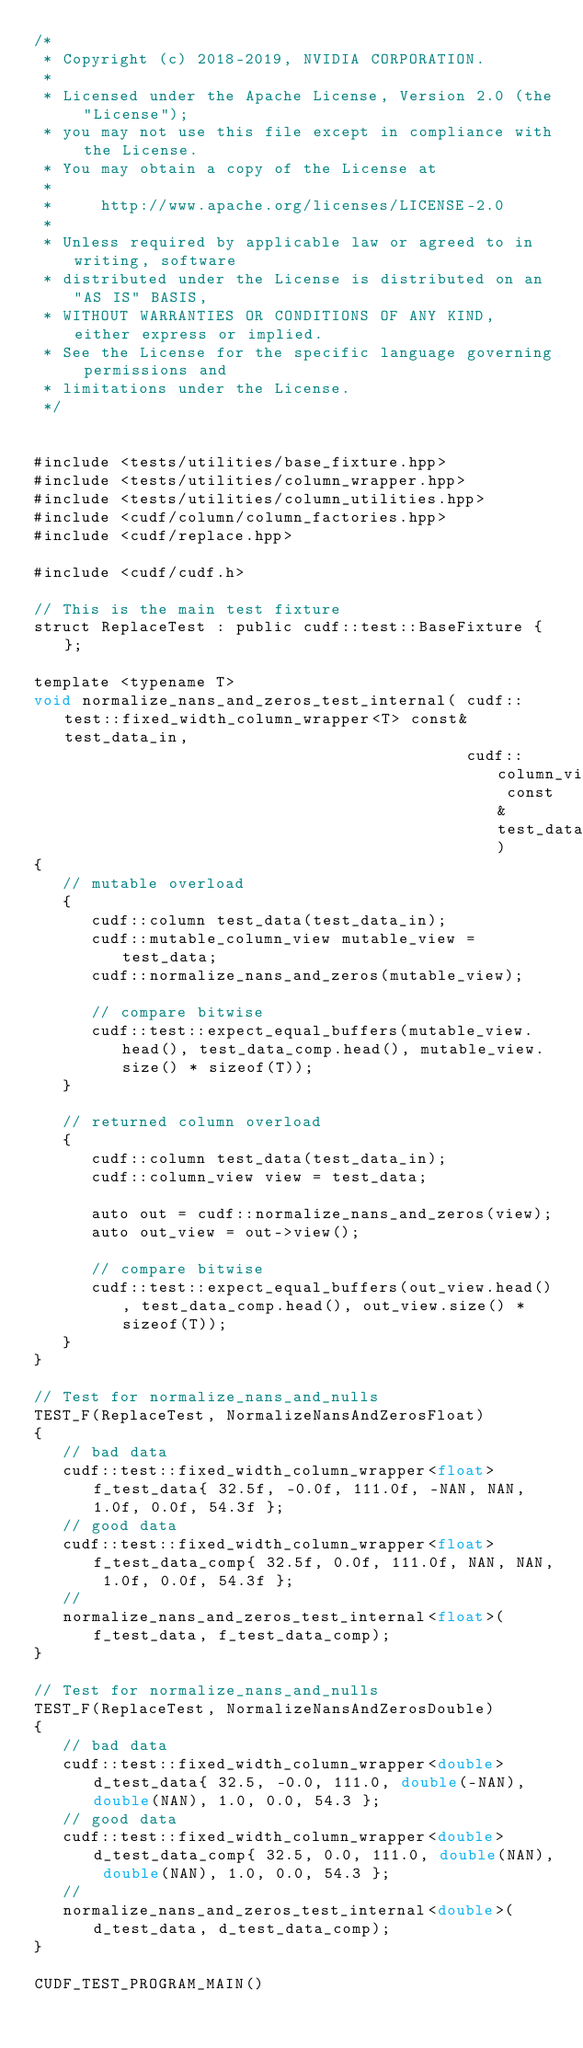<code> <loc_0><loc_0><loc_500><loc_500><_Cuda_>/*
 * Copyright (c) 2018-2019, NVIDIA CORPORATION.
 *
 * Licensed under the Apache License, Version 2.0 (the "License");
 * you may not use this file except in compliance with the License.
 * You may obtain a copy of the License at
 *
 *     http://www.apache.org/licenses/LICENSE-2.0
 *
 * Unless required by applicable law or agreed to in writing, software
 * distributed under the License is distributed on an "AS IS" BASIS,
 * WITHOUT WARRANTIES OR CONDITIONS OF ANY KIND, either express or implied.
 * See the License for the specific language governing permissions and
 * limitations under the License.
 */


#include <tests/utilities/base_fixture.hpp>
#include <tests/utilities/column_wrapper.hpp>
#include <tests/utilities/column_utilities.hpp>
#include <cudf/column/column_factories.hpp>
#include <cudf/replace.hpp>

#include <cudf/cudf.h>

// This is the main test fixture
struct ReplaceTest : public cudf::test::BaseFixture { };

template <typename T>
void normalize_nans_and_zeros_test_internal( cudf::test::fixed_width_column_wrapper<T> const& test_data_in,
                                             cudf::column_view const& test_data_comp)
{
   // mutable overload
   {
      cudf::column test_data(test_data_in);
      cudf::mutable_column_view mutable_view = test_data;
      cudf::normalize_nans_and_zeros(mutable_view);

      // compare bitwise
      cudf::test::expect_equal_buffers(mutable_view.head(), test_data_comp.head(), mutable_view.size() * sizeof(T));
   }

   // returned column overload
   {
      cudf::column test_data(test_data_in);
      cudf::column_view view = test_data;

      auto out = cudf::normalize_nans_and_zeros(view);
      auto out_view = out->view();

      // compare bitwise
      cudf::test::expect_equal_buffers(out_view.head(), test_data_comp.head(), out_view.size() * sizeof(T));
   }
}

// Test for normalize_nans_and_nulls
TEST_F(ReplaceTest, NormalizeNansAndZerosFloat)
{
   // bad data
   cudf::test::fixed_width_column_wrapper<float> f_test_data{ 32.5f, -0.0f, 111.0f, -NAN, NAN, 1.0f, 0.0f, 54.3f };
   // good data
   cudf::test::fixed_width_column_wrapper<float> f_test_data_comp{ 32.5f, 0.0f, 111.0f, NAN, NAN, 1.0f, 0.0f, 54.3f };
   //
   normalize_nans_and_zeros_test_internal<float>(f_test_data, f_test_data_comp);
}

// Test for normalize_nans_and_nulls
TEST_F(ReplaceTest, NormalizeNansAndZerosDouble)
{
   // bad data
   cudf::test::fixed_width_column_wrapper<double> d_test_data{ 32.5, -0.0, 111.0, double(-NAN), double(NAN), 1.0, 0.0, 54.3 };
   // good data
   cudf::test::fixed_width_column_wrapper<double> d_test_data_comp{ 32.5, 0.0, 111.0, double(NAN), double(NAN), 1.0, 0.0, 54.3 };
   //
   normalize_nans_and_zeros_test_internal<double>(d_test_data, d_test_data_comp);
}

CUDF_TEST_PROGRAM_MAIN()
</code> 